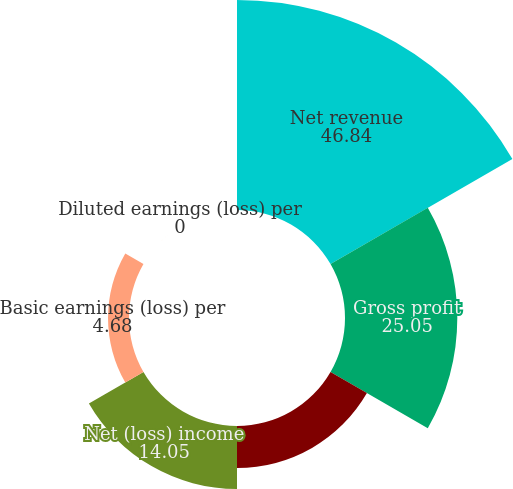<chart> <loc_0><loc_0><loc_500><loc_500><pie_chart><fcel>Net revenue<fcel>Gross profit<fcel>Income (loss) from operations<fcel>Net (loss) income<fcel>Basic earnings (loss) per<fcel>Diluted earnings (loss) per<nl><fcel>46.84%<fcel>25.05%<fcel>9.37%<fcel>14.05%<fcel>4.68%<fcel>0.0%<nl></chart> 